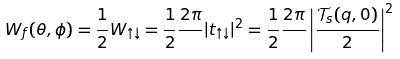Convert formula to latex. <formula><loc_0><loc_0><loc_500><loc_500>W _ { f } ( \theta , \phi ) = \frac { 1 } { 2 } W _ { \uparrow \downarrow } = \frac { 1 } { 2 } \frac { 2 \pi } { } | t _ { \uparrow \downarrow } | ^ { 2 } = \frac { 1 } { 2 } \frac { 2 \pi } { } \left | \frac { \mathcal { T } _ { s } ( q , 0 ) } { 2 } \right | ^ { 2 }</formula> 